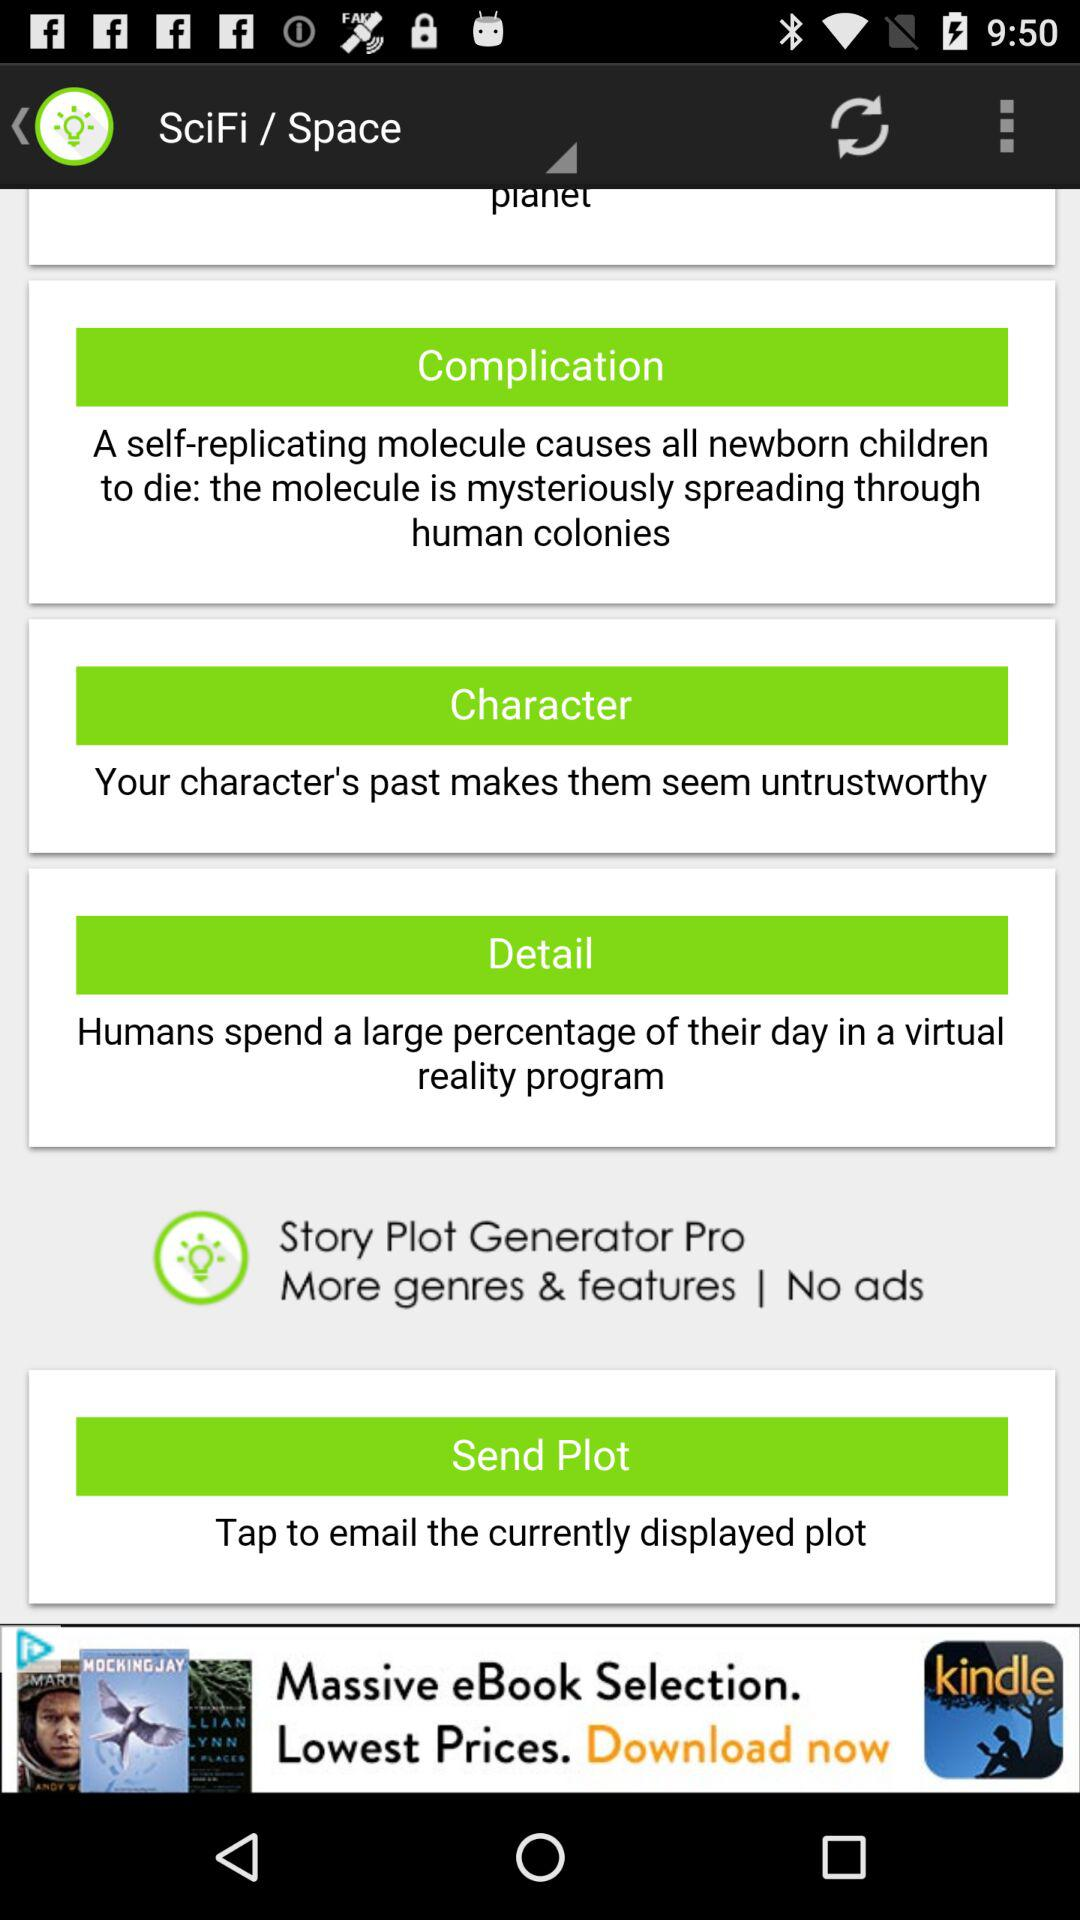Where did "humans" spend a large percentage of their day? Humans spend a large percentage of their day in virtual reality program. 